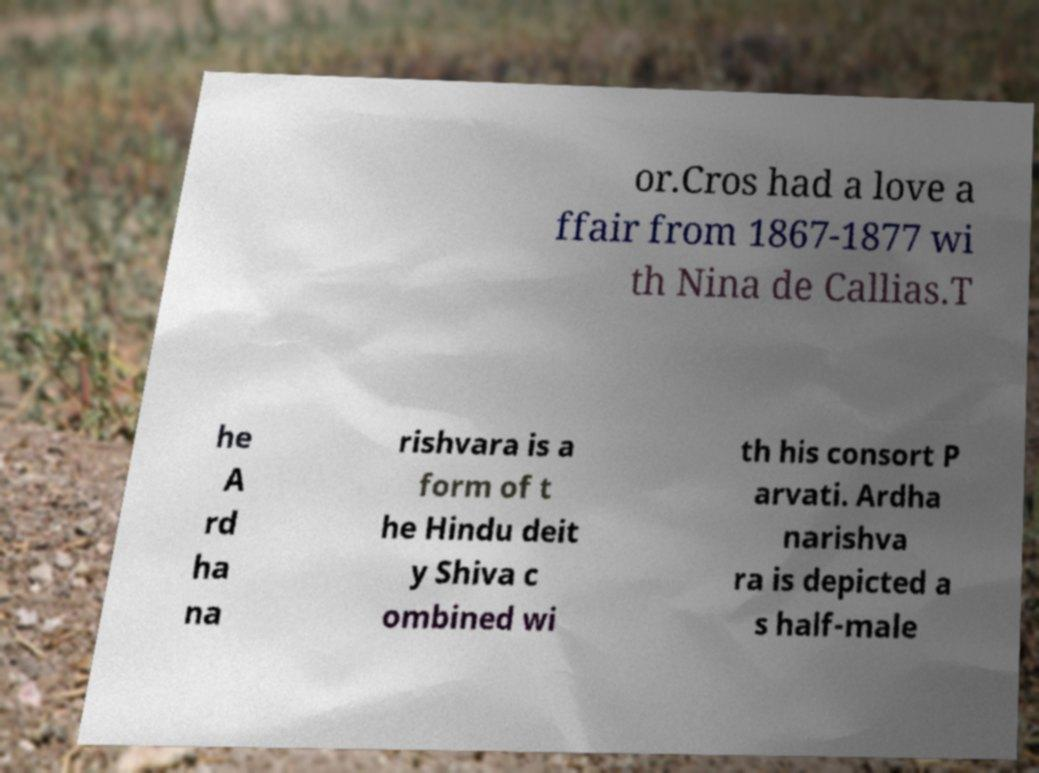I need the written content from this picture converted into text. Can you do that? or.Cros had a love a ffair from 1867-1877 wi th Nina de Callias.T he A rd ha na rishvara is a form of t he Hindu deit y Shiva c ombined wi th his consort P arvati. Ardha narishva ra is depicted a s half-male 